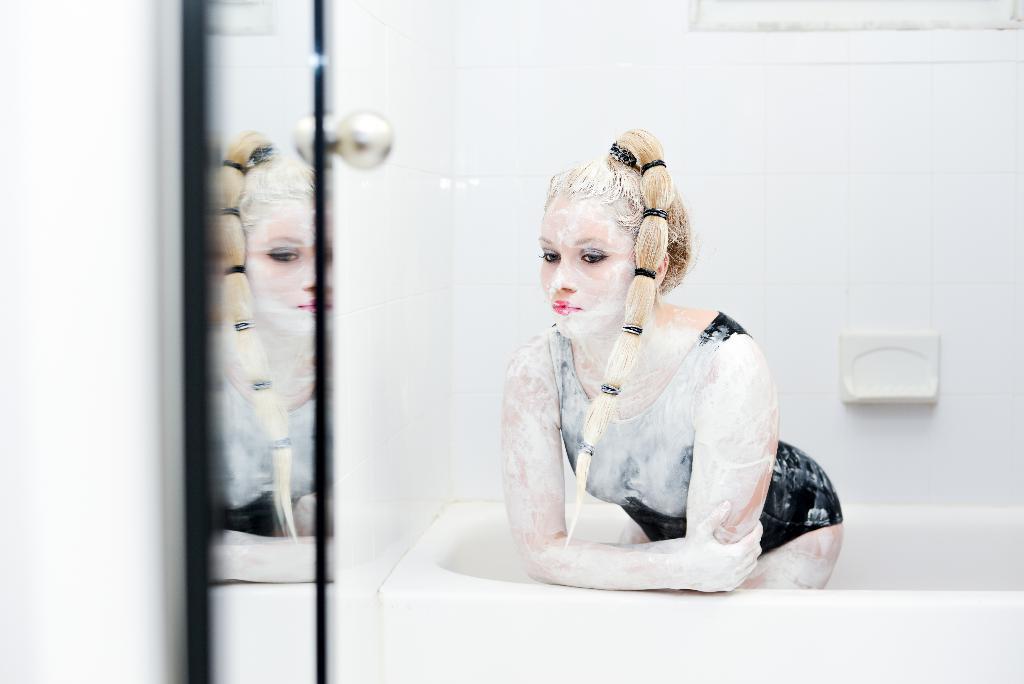How would you summarize this image in a sentence or two? In this picture, we see a woman is in the bathtub. She is posing for the photo. I think she is taking the bath. On the left side, we see a mirror. In the background, we see a wall which is made up of white color tiles. This picture is clicked in the washroom. 